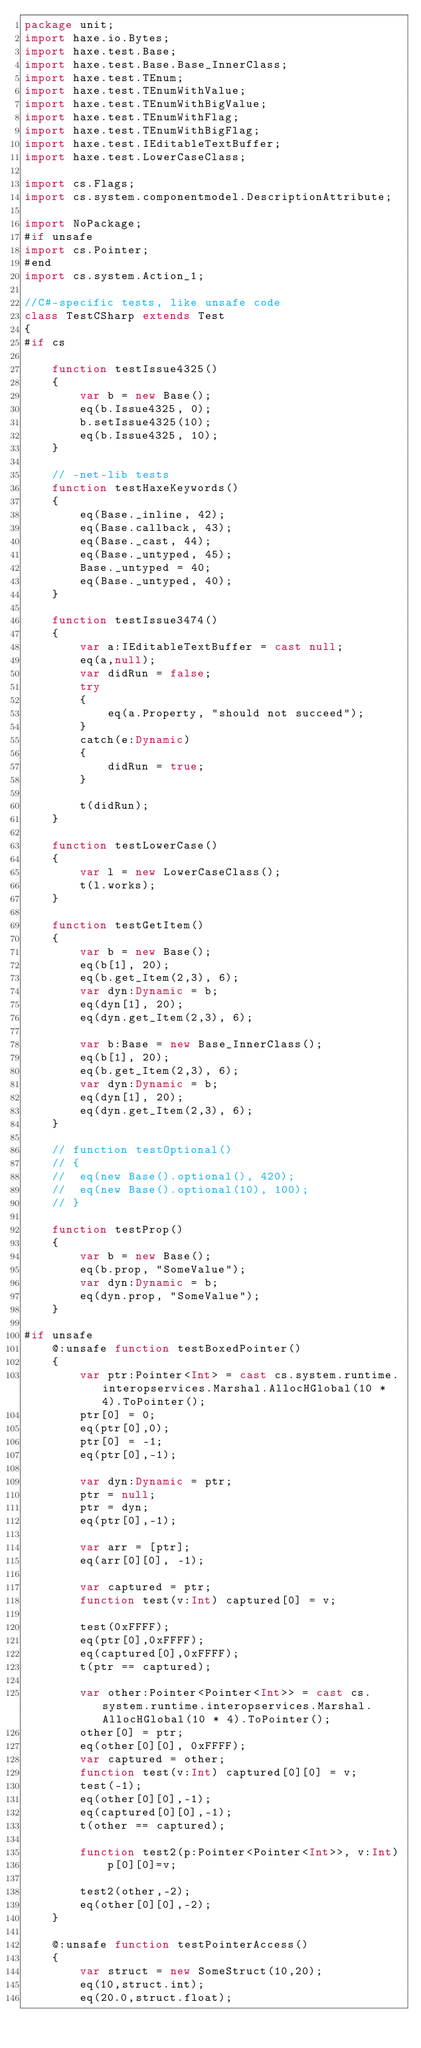Convert code to text. <code><loc_0><loc_0><loc_500><loc_500><_Haxe_>package unit;
import haxe.io.Bytes;
import haxe.test.Base;
import haxe.test.Base.Base_InnerClass;
import haxe.test.TEnum;
import haxe.test.TEnumWithValue;
import haxe.test.TEnumWithBigValue;
import haxe.test.TEnumWithFlag;
import haxe.test.TEnumWithBigFlag;
import haxe.test.IEditableTextBuffer;
import haxe.test.LowerCaseClass;

import cs.Flags;
import cs.system.componentmodel.DescriptionAttribute;

import NoPackage;
#if unsafe
import cs.Pointer;
#end
import cs.system.Action_1;

//C#-specific tests, like unsafe code
class TestCSharp extends Test
{
#if cs

	function testIssue4325()
	{
		var b = new Base();
		eq(b.Issue4325, 0);
		b.setIssue4325(10);
		eq(b.Issue4325, 10);
	}

	// -net-lib tests
	function testHaxeKeywords()
	{
		eq(Base._inline, 42);
		eq(Base.callback, 43);
		eq(Base._cast, 44);
		eq(Base._untyped, 45);
		Base._untyped = 40;
		eq(Base._untyped, 40);
	}

	function testIssue3474()
	{
		var a:IEditableTextBuffer = cast null;
		eq(a,null);
		var didRun = false;
		try
		{
			eq(a.Property, "should not succeed");
		}
		catch(e:Dynamic)
		{
			didRun = true;
		}

		t(didRun);
	}

	function testLowerCase()
	{
		var l = new LowerCaseClass();
		t(l.works);
	}

	function testGetItem()
	{
		var b = new Base();
		eq(b[1], 20);
		eq(b.get_Item(2,3), 6);
		var dyn:Dynamic = b;
		eq(dyn[1], 20);
		eq(dyn.get_Item(2,3), 6);

		var b:Base = new Base_InnerClass();
		eq(b[1], 20);
		eq(b.get_Item(2,3), 6);
		var dyn:Dynamic = b;
		eq(dyn[1], 20);
		eq(dyn.get_Item(2,3), 6);
	}

	// function testOptional()
	// {
	// 	eq(new Base().optional(), 420);
	// 	eq(new Base().optional(10), 100);
	// }

	function testProp()
	{
		var b = new Base();
		eq(b.prop, "SomeValue");
		var dyn:Dynamic = b;
		eq(dyn.prop, "SomeValue");
	}

#if unsafe
	@:unsafe function testBoxedPointer()
	{
		var ptr:Pointer<Int> = cast cs.system.runtime.interopservices.Marshal.AllocHGlobal(10 * 4).ToPointer();
		ptr[0] = 0;
		eq(ptr[0],0);
		ptr[0] = -1;
		eq(ptr[0],-1);

		var dyn:Dynamic = ptr;
		ptr = null;
		ptr = dyn;
		eq(ptr[0],-1);

		var arr = [ptr];
		eq(arr[0][0], -1);

		var captured = ptr;
		function test(v:Int) captured[0] = v;

		test(0xFFFF);
		eq(ptr[0],0xFFFF);
		eq(captured[0],0xFFFF);
		t(ptr == captured);

		var other:Pointer<Pointer<Int>> = cast cs.system.runtime.interopservices.Marshal.AllocHGlobal(10 * 4).ToPointer();
		other[0] = ptr;
		eq(other[0][0], 0xFFFF);
		var captured = other;
		function test(v:Int) captured[0][0] = v;
		test(-1);
		eq(other[0][0],-1);
		eq(captured[0][0],-1);
		t(other == captured);

		function test2(p:Pointer<Pointer<Int>>, v:Int)
			p[0][0]=v;

		test2(other,-2);
		eq(other[0][0],-2);
	}

	@:unsafe function testPointerAccess()
	{
		var struct = new SomeStruct(10,20);
		eq(10,struct.int);
		eq(20.0,struct.float);
</code> 